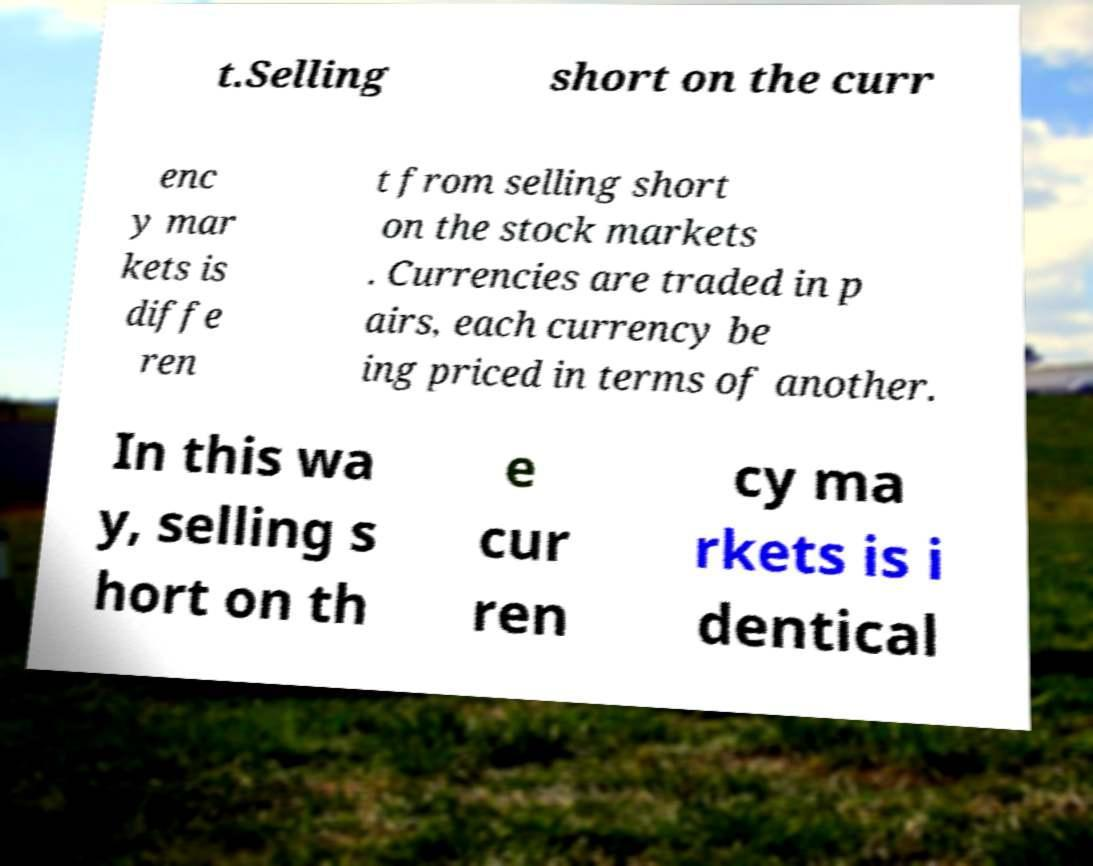Please read and relay the text visible in this image. What does it say? t.Selling short on the curr enc y mar kets is diffe ren t from selling short on the stock markets . Currencies are traded in p airs, each currency be ing priced in terms of another. In this wa y, selling s hort on th e cur ren cy ma rkets is i dentical 